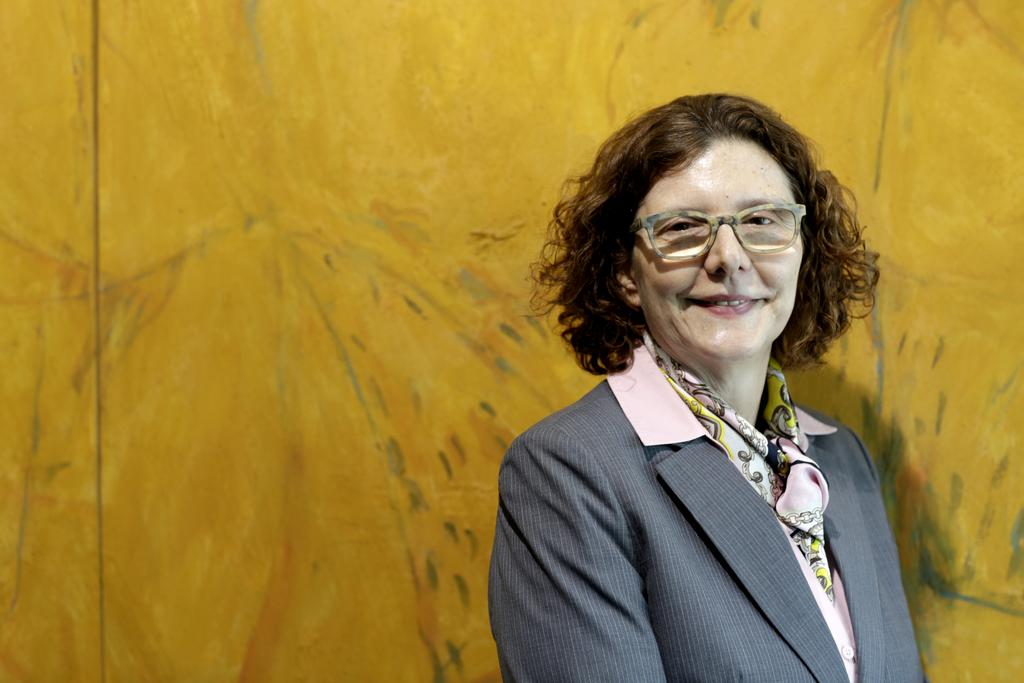Who is present in the image? There is a woman in the image. What is the woman doing in the image? The woman is smiling in the image. What accessory is the woman wearing? The woman is wearing spectacles in the image. What color is the background of the image? The background of the image is yellow. What type of stone can be seen in the woman's hand in the image? There is no stone present in the image, and the woman's hand is not visible. 